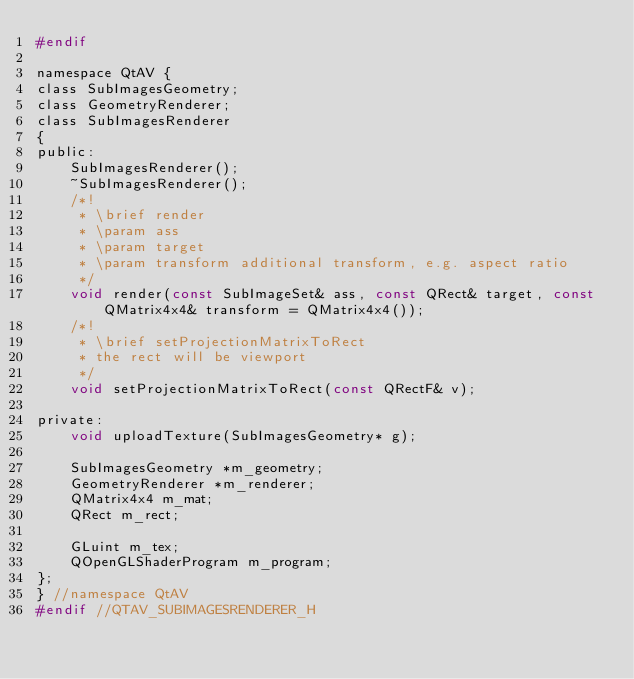<code> <loc_0><loc_0><loc_500><loc_500><_C_>#endif

namespace QtAV {
class SubImagesGeometry;
class GeometryRenderer;
class SubImagesRenderer
{
public:
    SubImagesRenderer();
    ~SubImagesRenderer();
    /*!
     * \brief render
     * \param ass
     * \param target
     * \param transform additional transform, e.g. aspect ratio
     */
    void render(const SubImageSet& ass, const QRect& target, const QMatrix4x4& transform = QMatrix4x4());
    /*!
     * \brief setProjectionMatrixToRect
     * the rect will be viewport
     */
    void setProjectionMatrixToRect(const QRectF& v);

private:
    void uploadTexture(SubImagesGeometry* g);

    SubImagesGeometry *m_geometry;
    GeometryRenderer *m_renderer;
    QMatrix4x4 m_mat;
    QRect m_rect;

    GLuint m_tex;
    QOpenGLShaderProgram m_program;
};
} //namespace QtAV
#endif //QTAV_SUBIMAGESRENDERER_H
</code> 